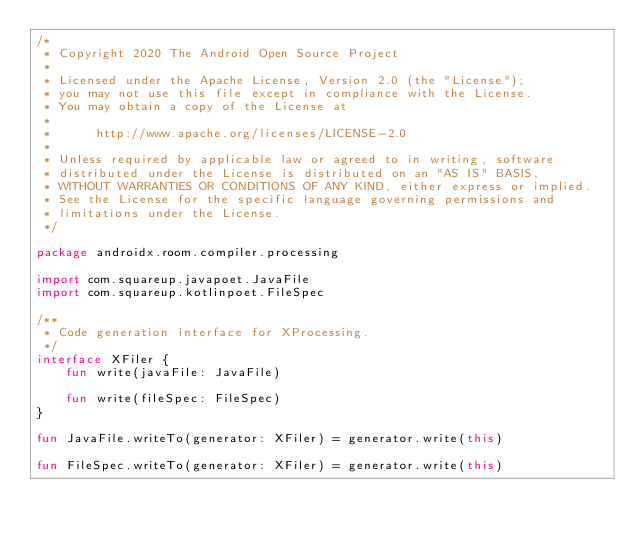<code> <loc_0><loc_0><loc_500><loc_500><_Kotlin_>/*
 * Copyright 2020 The Android Open Source Project
 *
 * Licensed under the Apache License, Version 2.0 (the "License");
 * you may not use this file except in compliance with the License.
 * You may obtain a copy of the License at
 *
 *      http://www.apache.org/licenses/LICENSE-2.0
 *
 * Unless required by applicable law or agreed to in writing, software
 * distributed under the License is distributed on an "AS IS" BASIS,
 * WITHOUT WARRANTIES OR CONDITIONS OF ANY KIND, either express or implied.
 * See the License for the specific language governing permissions and
 * limitations under the License.
 */

package androidx.room.compiler.processing

import com.squareup.javapoet.JavaFile
import com.squareup.kotlinpoet.FileSpec

/**
 * Code generation interface for XProcessing.
 */
interface XFiler {
    fun write(javaFile: JavaFile)

    fun write(fileSpec: FileSpec)
}

fun JavaFile.writeTo(generator: XFiler) = generator.write(this)

fun FileSpec.writeTo(generator: XFiler) = generator.write(this)
</code> 